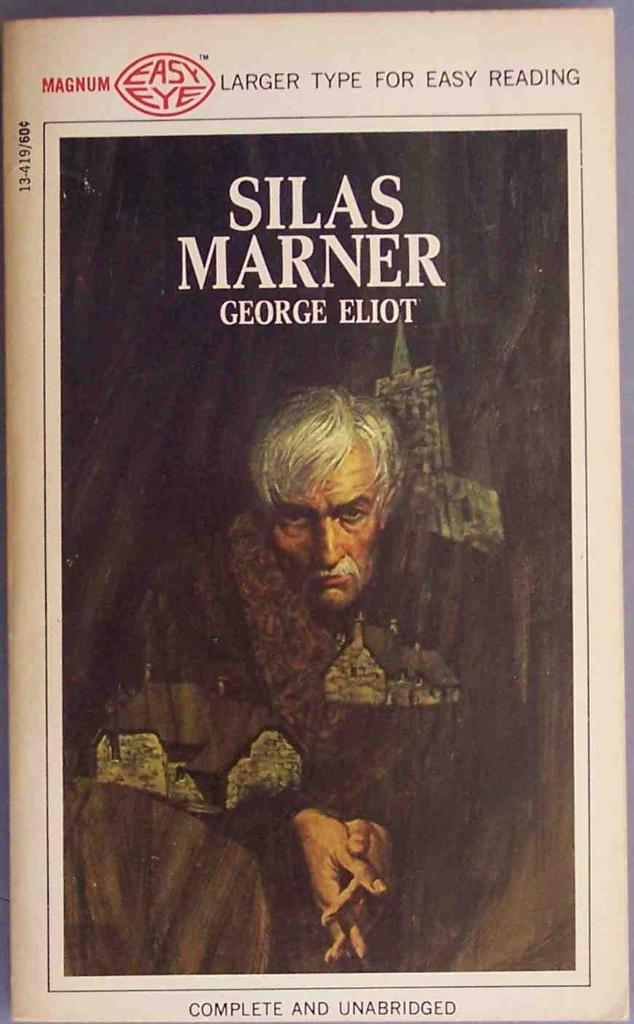<image>
Render a clear and concise summary of the photo. Book cover for Silas Marner written by George Eliot showing a man with his hands together. 